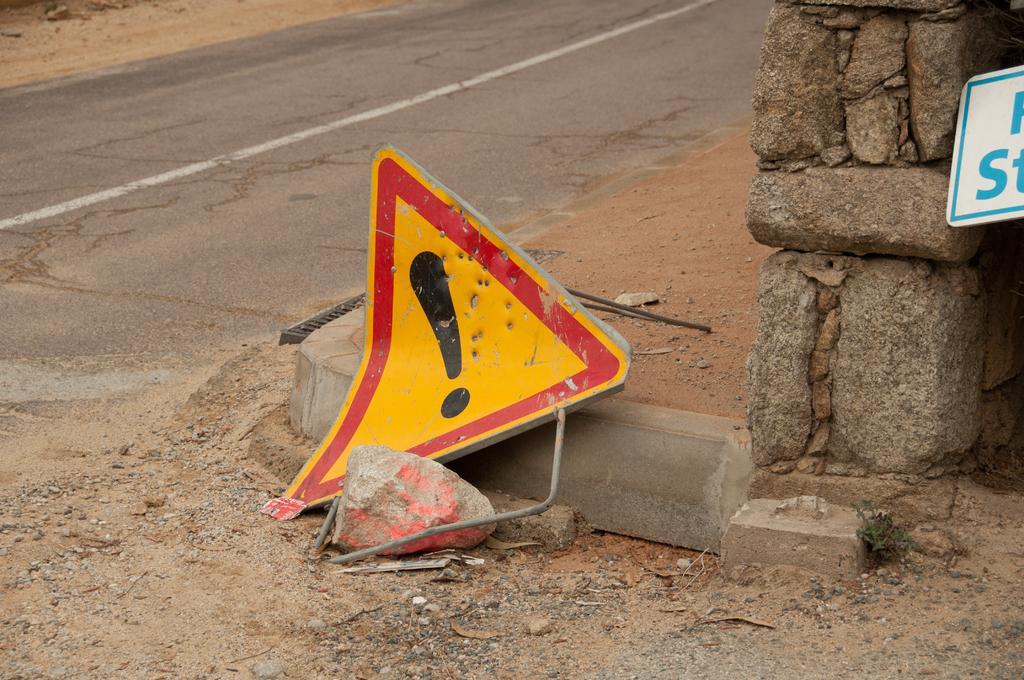In one or two sentences, can you explain what this image depicts? In the center of the image we can see one sign board, stones and a few other objects. On the right side of the image, there is a wall, one sign board etc. In the background there is a road. 